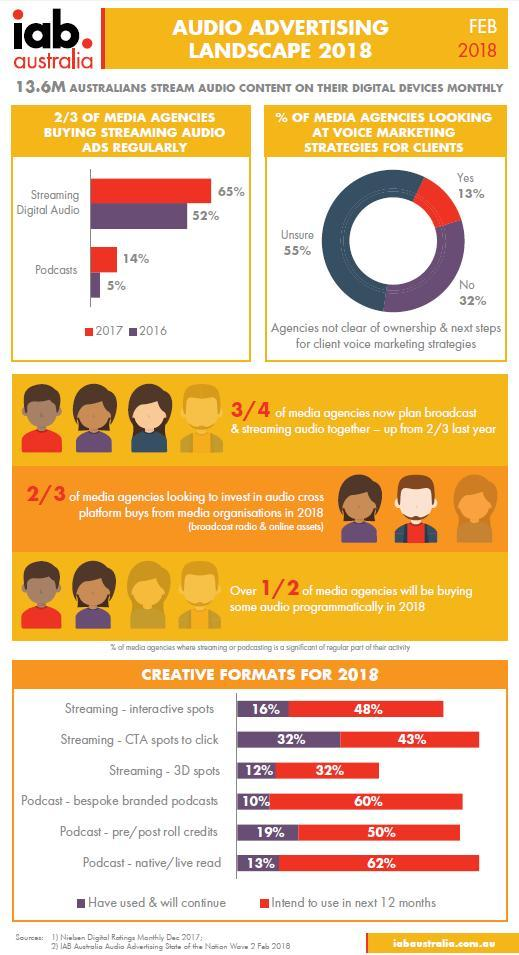how many look at voice marketing strategies for clients
Answer the question with a short phrase. 13% how many times is 2018 mentioned in the document 6 how many intend to use streaming - 3D spots 32% how many have been streaming digital audio in 2016 52 how many are not looking at using voice marketing strategies for clients 32% podcast percentage in 2017? 14 which creative format has been used the least podcast - bespoke branded podcasts which are the years mentioned in the image 2018, 2017, 2016 